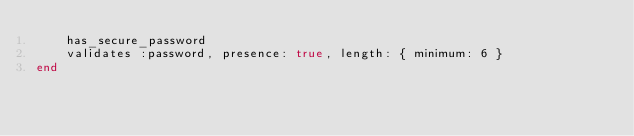<code> <loc_0><loc_0><loc_500><loc_500><_Ruby_>    has_secure_password 
    validates :password, presence: true, length: { minimum: 6 }
end
</code> 